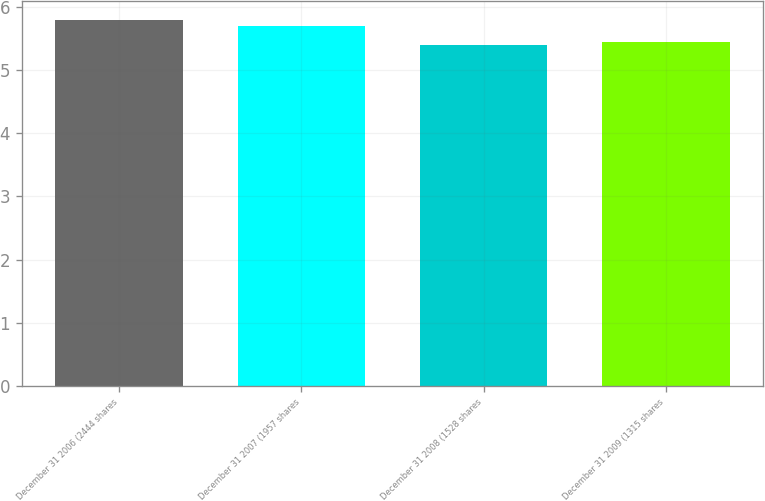Convert chart to OTSL. <chart><loc_0><loc_0><loc_500><loc_500><bar_chart><fcel>December 31 2006 (2444 shares<fcel>December 31 2007 (1957 shares<fcel>December 31 2008 (1528 shares<fcel>December 31 2009 (1315 shares<nl><fcel>5.8<fcel>5.7<fcel>5.4<fcel>5.44<nl></chart> 